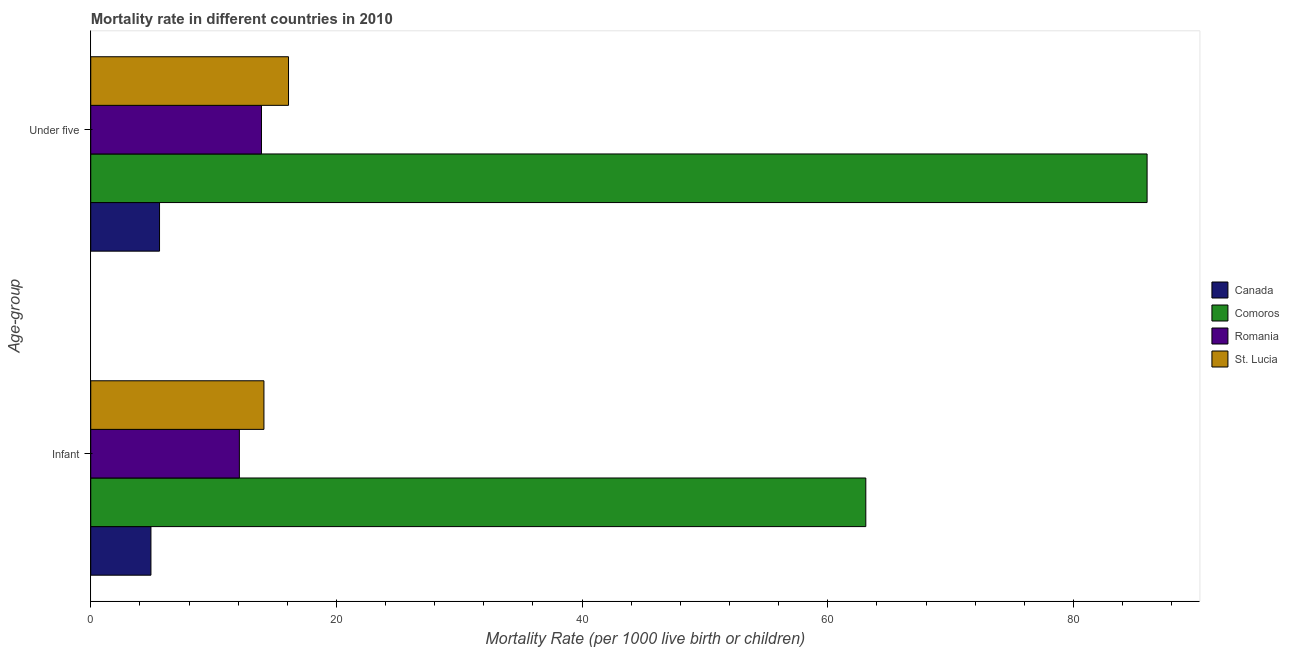Are the number of bars per tick equal to the number of legend labels?
Provide a succinct answer. Yes. How many bars are there on the 1st tick from the bottom?
Your answer should be compact. 4. What is the label of the 2nd group of bars from the top?
Offer a terse response. Infant. Across all countries, what is the minimum under-5 mortality rate?
Make the answer very short. 5.6. In which country was the under-5 mortality rate maximum?
Make the answer very short. Comoros. What is the total infant mortality rate in the graph?
Give a very brief answer. 94.2. What is the difference between the infant mortality rate in Canada and that in St. Lucia?
Your answer should be compact. -9.2. What is the difference between the under-5 mortality rate in Romania and the infant mortality rate in Comoros?
Your answer should be very brief. -49.2. What is the average infant mortality rate per country?
Offer a very short reply. 23.55. What is the difference between the under-5 mortality rate and infant mortality rate in Canada?
Your response must be concise. 0.7. What is the ratio of the infant mortality rate in Romania to that in St. Lucia?
Keep it short and to the point. 0.86. Is the under-5 mortality rate in St. Lucia less than that in Romania?
Your answer should be compact. No. What does the 1st bar from the top in Infant represents?
Your answer should be compact. St. Lucia. What does the 1st bar from the bottom in Infant represents?
Provide a succinct answer. Canada. How many bars are there?
Offer a very short reply. 8. Are all the bars in the graph horizontal?
Ensure brevity in your answer.  Yes. How many countries are there in the graph?
Provide a short and direct response. 4. How are the legend labels stacked?
Give a very brief answer. Vertical. What is the title of the graph?
Make the answer very short. Mortality rate in different countries in 2010. What is the label or title of the X-axis?
Give a very brief answer. Mortality Rate (per 1000 live birth or children). What is the label or title of the Y-axis?
Your answer should be compact. Age-group. What is the Mortality Rate (per 1000 live birth or children) of Comoros in Infant?
Offer a very short reply. 63.1. What is the Mortality Rate (per 1000 live birth or children) in Romania in Infant?
Give a very brief answer. 12.1. What is the Mortality Rate (per 1000 live birth or children) in St. Lucia in Under five?
Offer a terse response. 16.1. Across all Age-group, what is the maximum Mortality Rate (per 1000 live birth or children) in Canada?
Your answer should be compact. 5.6. Across all Age-group, what is the maximum Mortality Rate (per 1000 live birth or children) of Comoros?
Provide a succinct answer. 86. Across all Age-group, what is the maximum Mortality Rate (per 1000 live birth or children) of St. Lucia?
Your answer should be compact. 16.1. Across all Age-group, what is the minimum Mortality Rate (per 1000 live birth or children) in Canada?
Ensure brevity in your answer.  4.9. Across all Age-group, what is the minimum Mortality Rate (per 1000 live birth or children) in Comoros?
Your answer should be very brief. 63.1. Across all Age-group, what is the minimum Mortality Rate (per 1000 live birth or children) in Romania?
Your answer should be very brief. 12.1. What is the total Mortality Rate (per 1000 live birth or children) in Canada in the graph?
Offer a very short reply. 10.5. What is the total Mortality Rate (per 1000 live birth or children) of Comoros in the graph?
Make the answer very short. 149.1. What is the total Mortality Rate (per 1000 live birth or children) of Romania in the graph?
Provide a short and direct response. 26. What is the total Mortality Rate (per 1000 live birth or children) in St. Lucia in the graph?
Your response must be concise. 30.2. What is the difference between the Mortality Rate (per 1000 live birth or children) of Canada in Infant and that in Under five?
Give a very brief answer. -0.7. What is the difference between the Mortality Rate (per 1000 live birth or children) in Comoros in Infant and that in Under five?
Make the answer very short. -22.9. What is the difference between the Mortality Rate (per 1000 live birth or children) of St. Lucia in Infant and that in Under five?
Your answer should be very brief. -2. What is the difference between the Mortality Rate (per 1000 live birth or children) in Canada in Infant and the Mortality Rate (per 1000 live birth or children) in Comoros in Under five?
Your answer should be very brief. -81.1. What is the difference between the Mortality Rate (per 1000 live birth or children) in Canada in Infant and the Mortality Rate (per 1000 live birth or children) in Romania in Under five?
Make the answer very short. -9. What is the difference between the Mortality Rate (per 1000 live birth or children) in Comoros in Infant and the Mortality Rate (per 1000 live birth or children) in Romania in Under five?
Make the answer very short. 49.2. What is the difference between the Mortality Rate (per 1000 live birth or children) in Comoros in Infant and the Mortality Rate (per 1000 live birth or children) in St. Lucia in Under five?
Keep it short and to the point. 47. What is the difference between the Mortality Rate (per 1000 live birth or children) in Romania in Infant and the Mortality Rate (per 1000 live birth or children) in St. Lucia in Under five?
Your response must be concise. -4. What is the average Mortality Rate (per 1000 live birth or children) of Canada per Age-group?
Your answer should be very brief. 5.25. What is the average Mortality Rate (per 1000 live birth or children) of Comoros per Age-group?
Provide a short and direct response. 74.55. What is the average Mortality Rate (per 1000 live birth or children) in Romania per Age-group?
Make the answer very short. 13. What is the difference between the Mortality Rate (per 1000 live birth or children) of Canada and Mortality Rate (per 1000 live birth or children) of Comoros in Infant?
Provide a short and direct response. -58.2. What is the difference between the Mortality Rate (per 1000 live birth or children) of Canada and Mortality Rate (per 1000 live birth or children) of Romania in Infant?
Ensure brevity in your answer.  -7.2. What is the difference between the Mortality Rate (per 1000 live birth or children) in Canada and Mortality Rate (per 1000 live birth or children) in St. Lucia in Infant?
Give a very brief answer. -9.2. What is the difference between the Mortality Rate (per 1000 live birth or children) in Comoros and Mortality Rate (per 1000 live birth or children) in St. Lucia in Infant?
Give a very brief answer. 49. What is the difference between the Mortality Rate (per 1000 live birth or children) of Romania and Mortality Rate (per 1000 live birth or children) of St. Lucia in Infant?
Ensure brevity in your answer.  -2. What is the difference between the Mortality Rate (per 1000 live birth or children) of Canada and Mortality Rate (per 1000 live birth or children) of Comoros in Under five?
Offer a very short reply. -80.4. What is the difference between the Mortality Rate (per 1000 live birth or children) of Comoros and Mortality Rate (per 1000 live birth or children) of Romania in Under five?
Ensure brevity in your answer.  72.1. What is the difference between the Mortality Rate (per 1000 live birth or children) in Comoros and Mortality Rate (per 1000 live birth or children) in St. Lucia in Under five?
Offer a very short reply. 69.9. What is the ratio of the Mortality Rate (per 1000 live birth or children) in Canada in Infant to that in Under five?
Make the answer very short. 0.88. What is the ratio of the Mortality Rate (per 1000 live birth or children) in Comoros in Infant to that in Under five?
Make the answer very short. 0.73. What is the ratio of the Mortality Rate (per 1000 live birth or children) in Romania in Infant to that in Under five?
Keep it short and to the point. 0.87. What is the ratio of the Mortality Rate (per 1000 live birth or children) in St. Lucia in Infant to that in Under five?
Offer a terse response. 0.88. What is the difference between the highest and the second highest Mortality Rate (per 1000 live birth or children) in Comoros?
Ensure brevity in your answer.  22.9. What is the difference between the highest and the lowest Mortality Rate (per 1000 live birth or children) of Comoros?
Give a very brief answer. 22.9. What is the difference between the highest and the lowest Mortality Rate (per 1000 live birth or children) of Romania?
Provide a succinct answer. 1.8. 